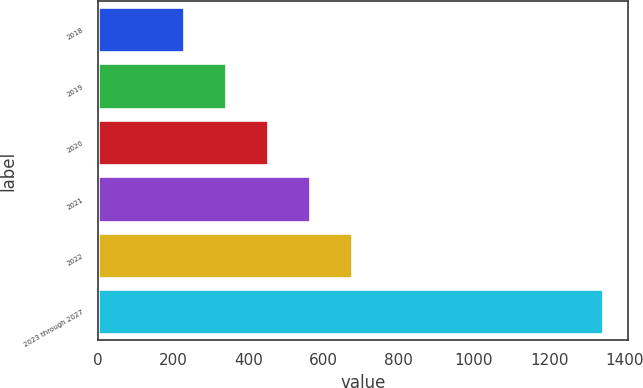Convert chart to OTSL. <chart><loc_0><loc_0><loc_500><loc_500><bar_chart><fcel>2018<fcel>2019<fcel>2020<fcel>2021<fcel>2022<fcel>2023 through 2027<nl><fcel>230<fcel>341.2<fcel>452.4<fcel>563.6<fcel>674.8<fcel>1342<nl></chart> 